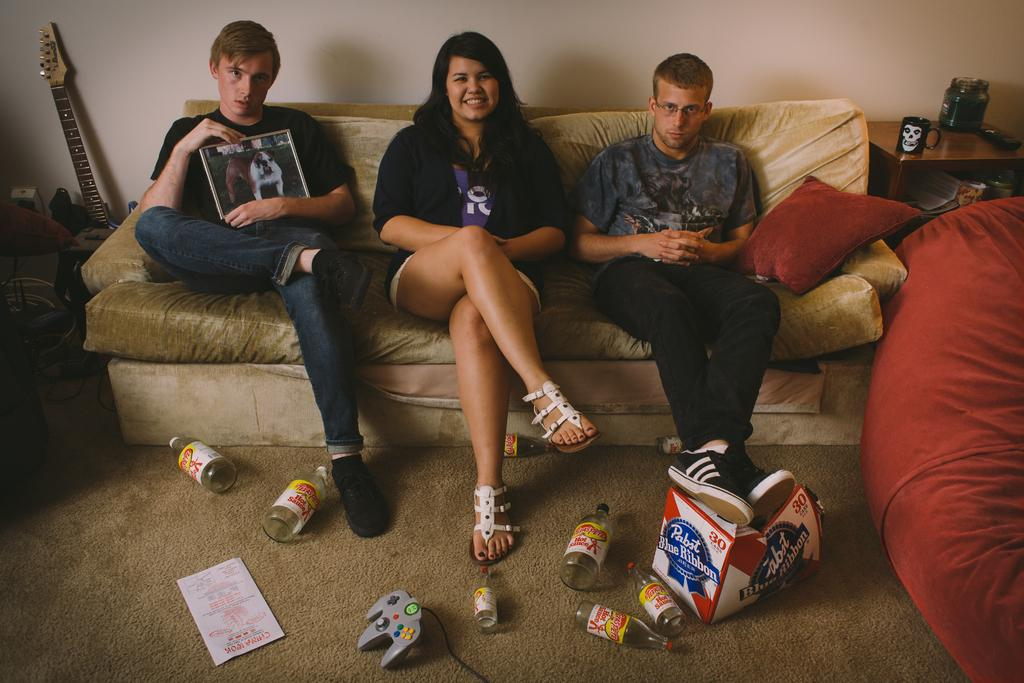<image>
Relay a brief, clear account of the picture shown. Three people sitting on a couch and one holding a photo of a dog and in the floor hot sauce and an empty carton of Pabst Blue Ribbon. 